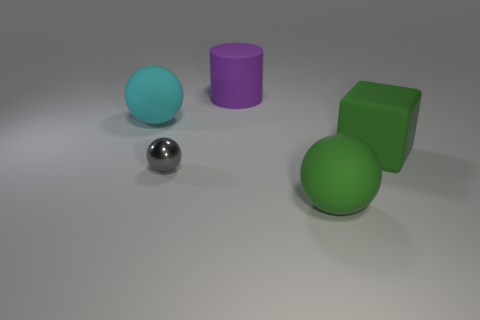Are there more large blue rubber spheres than small metallic balls?
Your answer should be very brief. No. The cube that is the same material as the large green ball is what size?
Keep it short and to the point. Large. Is the size of the gray shiny object that is in front of the big cylinder the same as the sphere that is to the right of the shiny ball?
Offer a terse response. No. What number of things are either big rubber spheres in front of the small ball or large yellow blocks?
Ensure brevity in your answer.  1. Are there fewer big blocks than tiny gray metallic cylinders?
Provide a short and direct response. No. What shape is the rubber thing that is behind the big matte sphere to the left of the rubber ball that is on the right side of the big cyan sphere?
Give a very brief answer. Cylinder. There is a big thing that is the same color as the big cube; what shape is it?
Give a very brief answer. Sphere. Are any large purple cylinders visible?
Offer a terse response. Yes. There is a cube; is it the same size as the matte sphere behind the big green sphere?
Give a very brief answer. Yes. Is there a green object in front of the green matte thing to the left of the big green rubber cube?
Offer a terse response. No. 